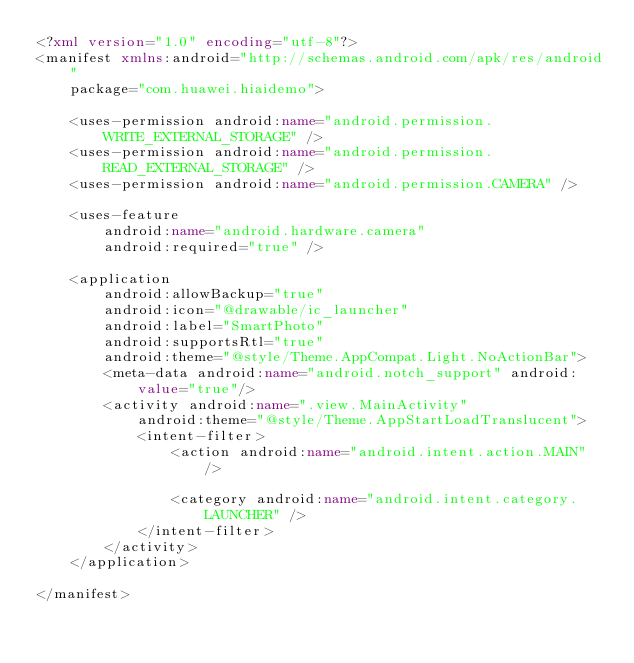Convert code to text. <code><loc_0><loc_0><loc_500><loc_500><_XML_><?xml version="1.0" encoding="utf-8"?>
<manifest xmlns:android="http://schemas.android.com/apk/res/android"
    package="com.huawei.hiaidemo">

    <uses-permission android:name="android.permission.WRITE_EXTERNAL_STORAGE" />
    <uses-permission android:name="android.permission.READ_EXTERNAL_STORAGE" />
    <uses-permission android:name="android.permission.CAMERA" />

    <uses-feature
        android:name="android.hardware.camera"
        android:required="true" />

    <application
        android:allowBackup="true"
        android:icon="@drawable/ic_launcher"
        android:label="SmartPhoto"
        android:supportsRtl="true"
        android:theme="@style/Theme.AppCompat.Light.NoActionBar">
        <meta-data android:name="android.notch_support" android:value="true"/>
        <activity android:name=".view.MainActivity"
            android:theme="@style/Theme.AppStartLoadTranslucent">
            <intent-filter>
                <action android:name="android.intent.action.MAIN" />

                <category android:name="android.intent.category.LAUNCHER" />
            </intent-filter>
        </activity>
    </application>

</manifest></code> 